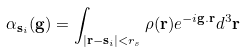<formula> <loc_0><loc_0><loc_500><loc_500>\alpha _ { { \mathbf s } _ { i } } ( { \mathbf g } ) = \int _ { | { \mathbf r } - { \mathbf s } _ { i } | < r _ { s } } \rho ( { \mathbf r } ) e ^ { - i { \mathbf g } . { \mathbf r } } d ^ { 3 } { \mathbf r }</formula> 